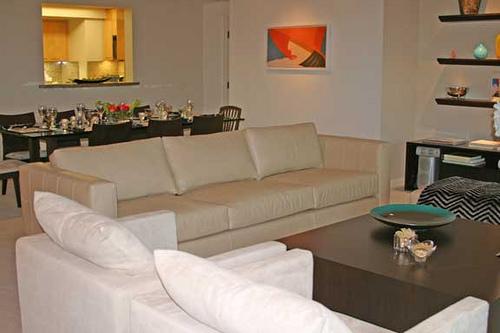Are the light on or off?
Quick response, please. On. Is the dining room table set?
Keep it brief. Yes. How is the ottoman patterned?
Write a very short answer. Chevron. What color is the chair in the corner?
Keep it brief. White. What is on the table?
Short answer required. Bowl. What is the object in the picture on the wall?
Short answer required. Woman. 